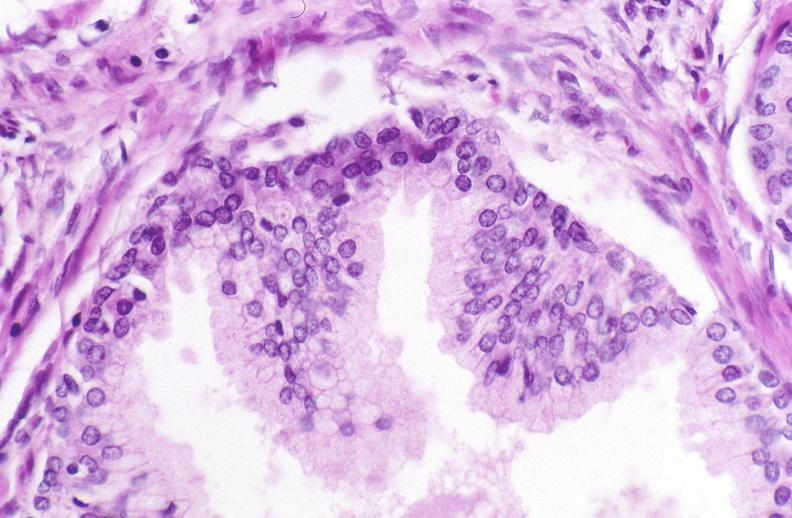what does this image show?
Answer the question using a single word or phrase. Prostate 